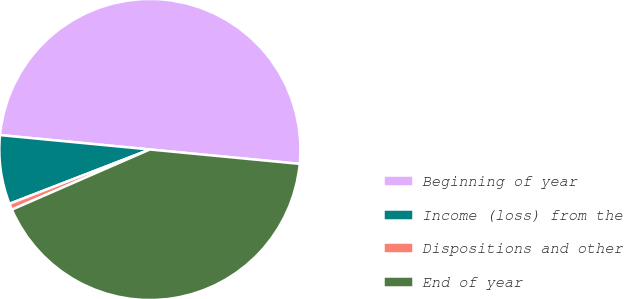Convert chart. <chart><loc_0><loc_0><loc_500><loc_500><pie_chart><fcel>Beginning of year<fcel>Income (loss) from the<fcel>Dispositions and other<fcel>End of year<nl><fcel>50.0%<fcel>7.4%<fcel>0.67%<fcel>41.93%<nl></chart> 